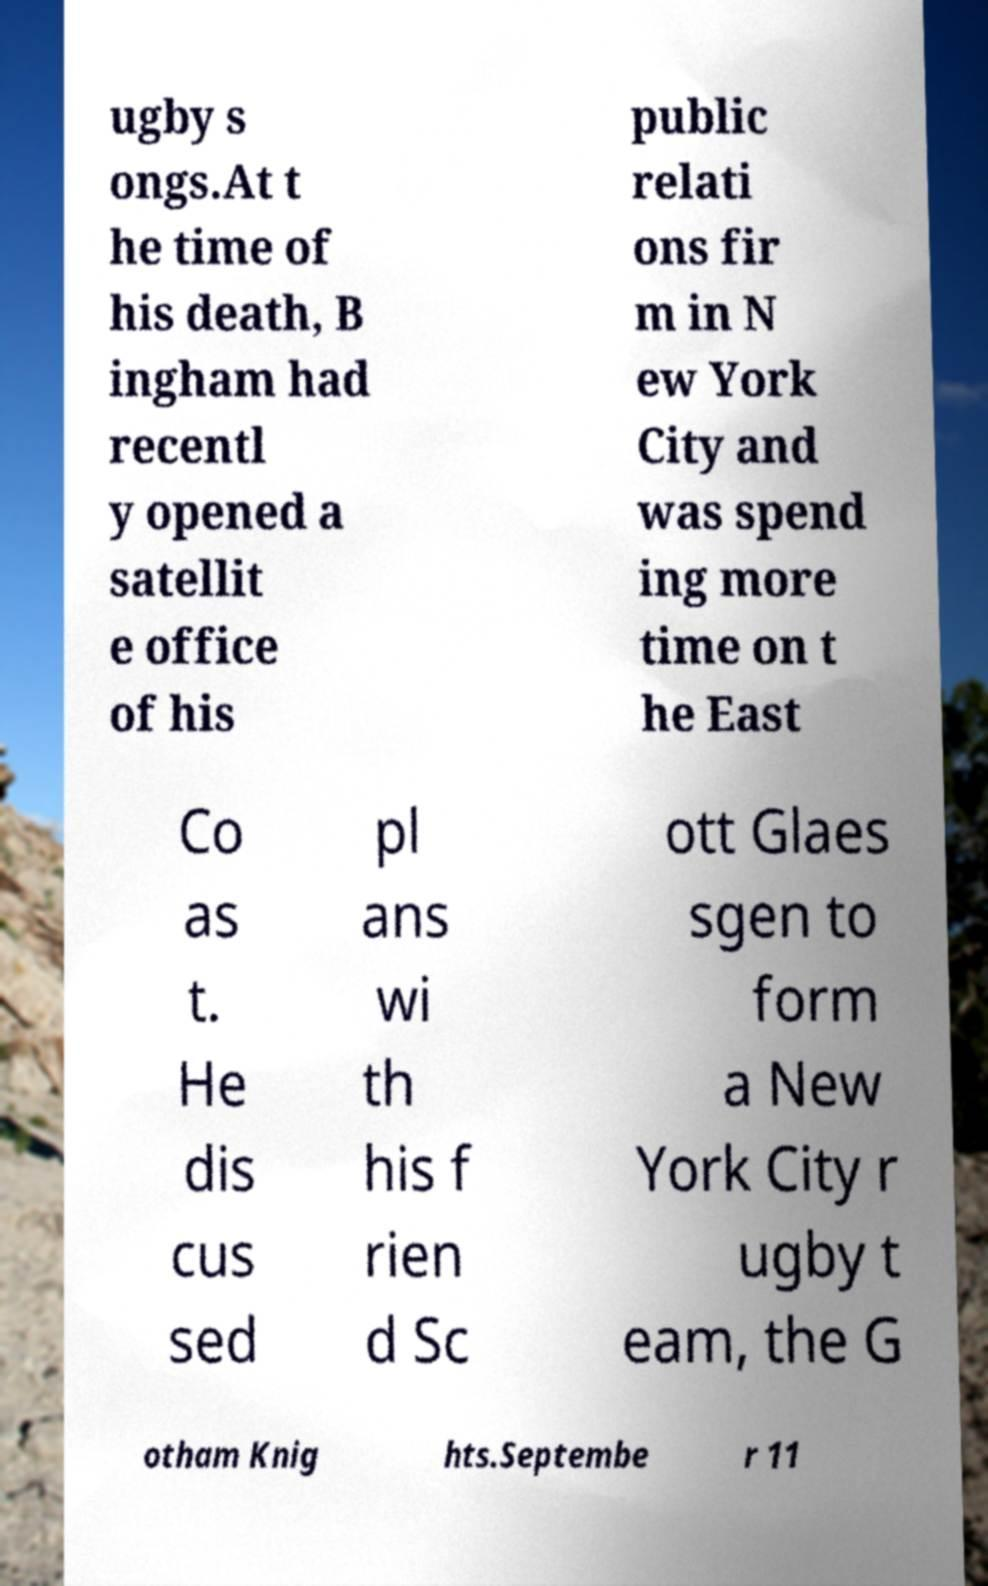I need the written content from this picture converted into text. Can you do that? ugby s ongs.At t he time of his death, B ingham had recentl y opened a satellit e office of his public relati ons fir m in N ew York City and was spend ing more time on t he East Co as t. He dis cus sed pl ans wi th his f rien d Sc ott Glaes sgen to form a New York City r ugby t eam, the G otham Knig hts.Septembe r 11 